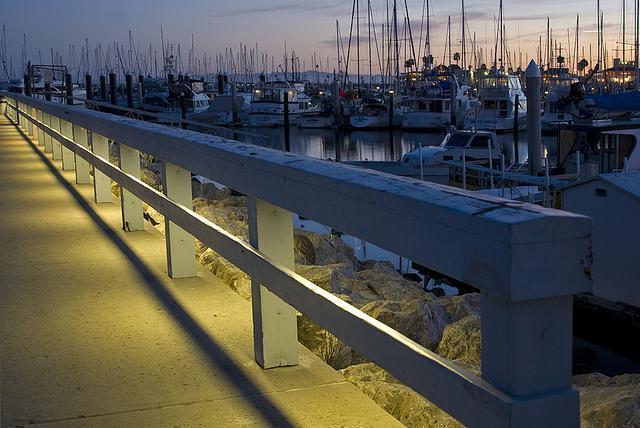How many boats are there?
Give a very brief answer. 5. 